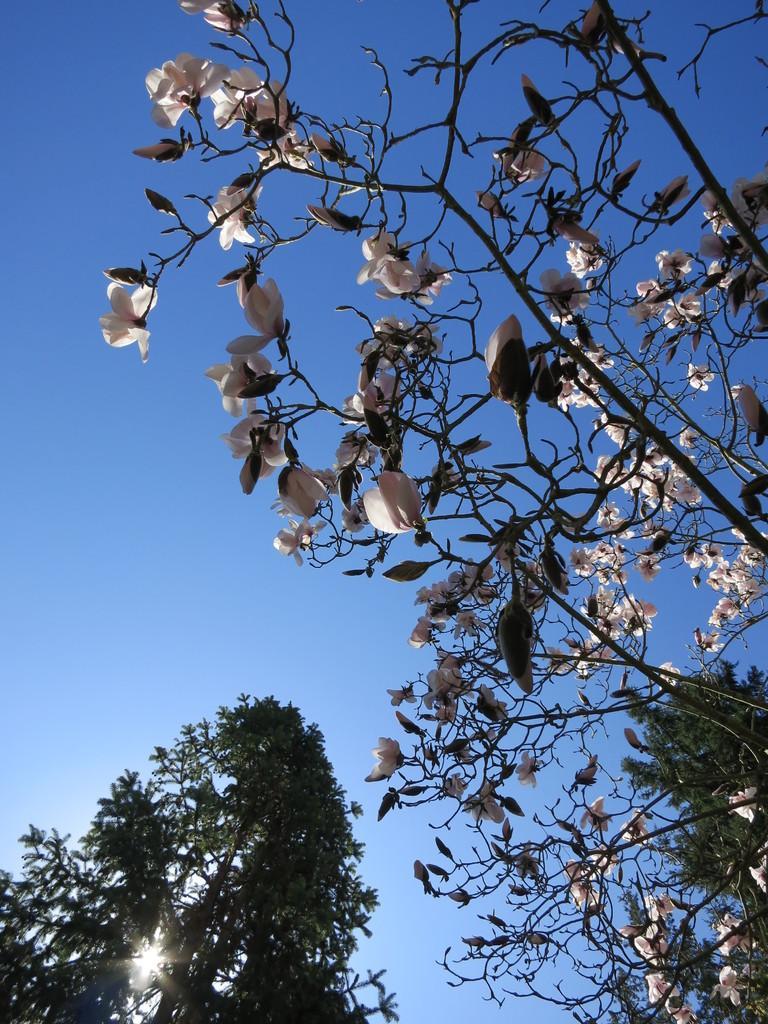Describe this image in one or two sentences. In this image we can see the trees and in the background we can see the sky and also the sun. 